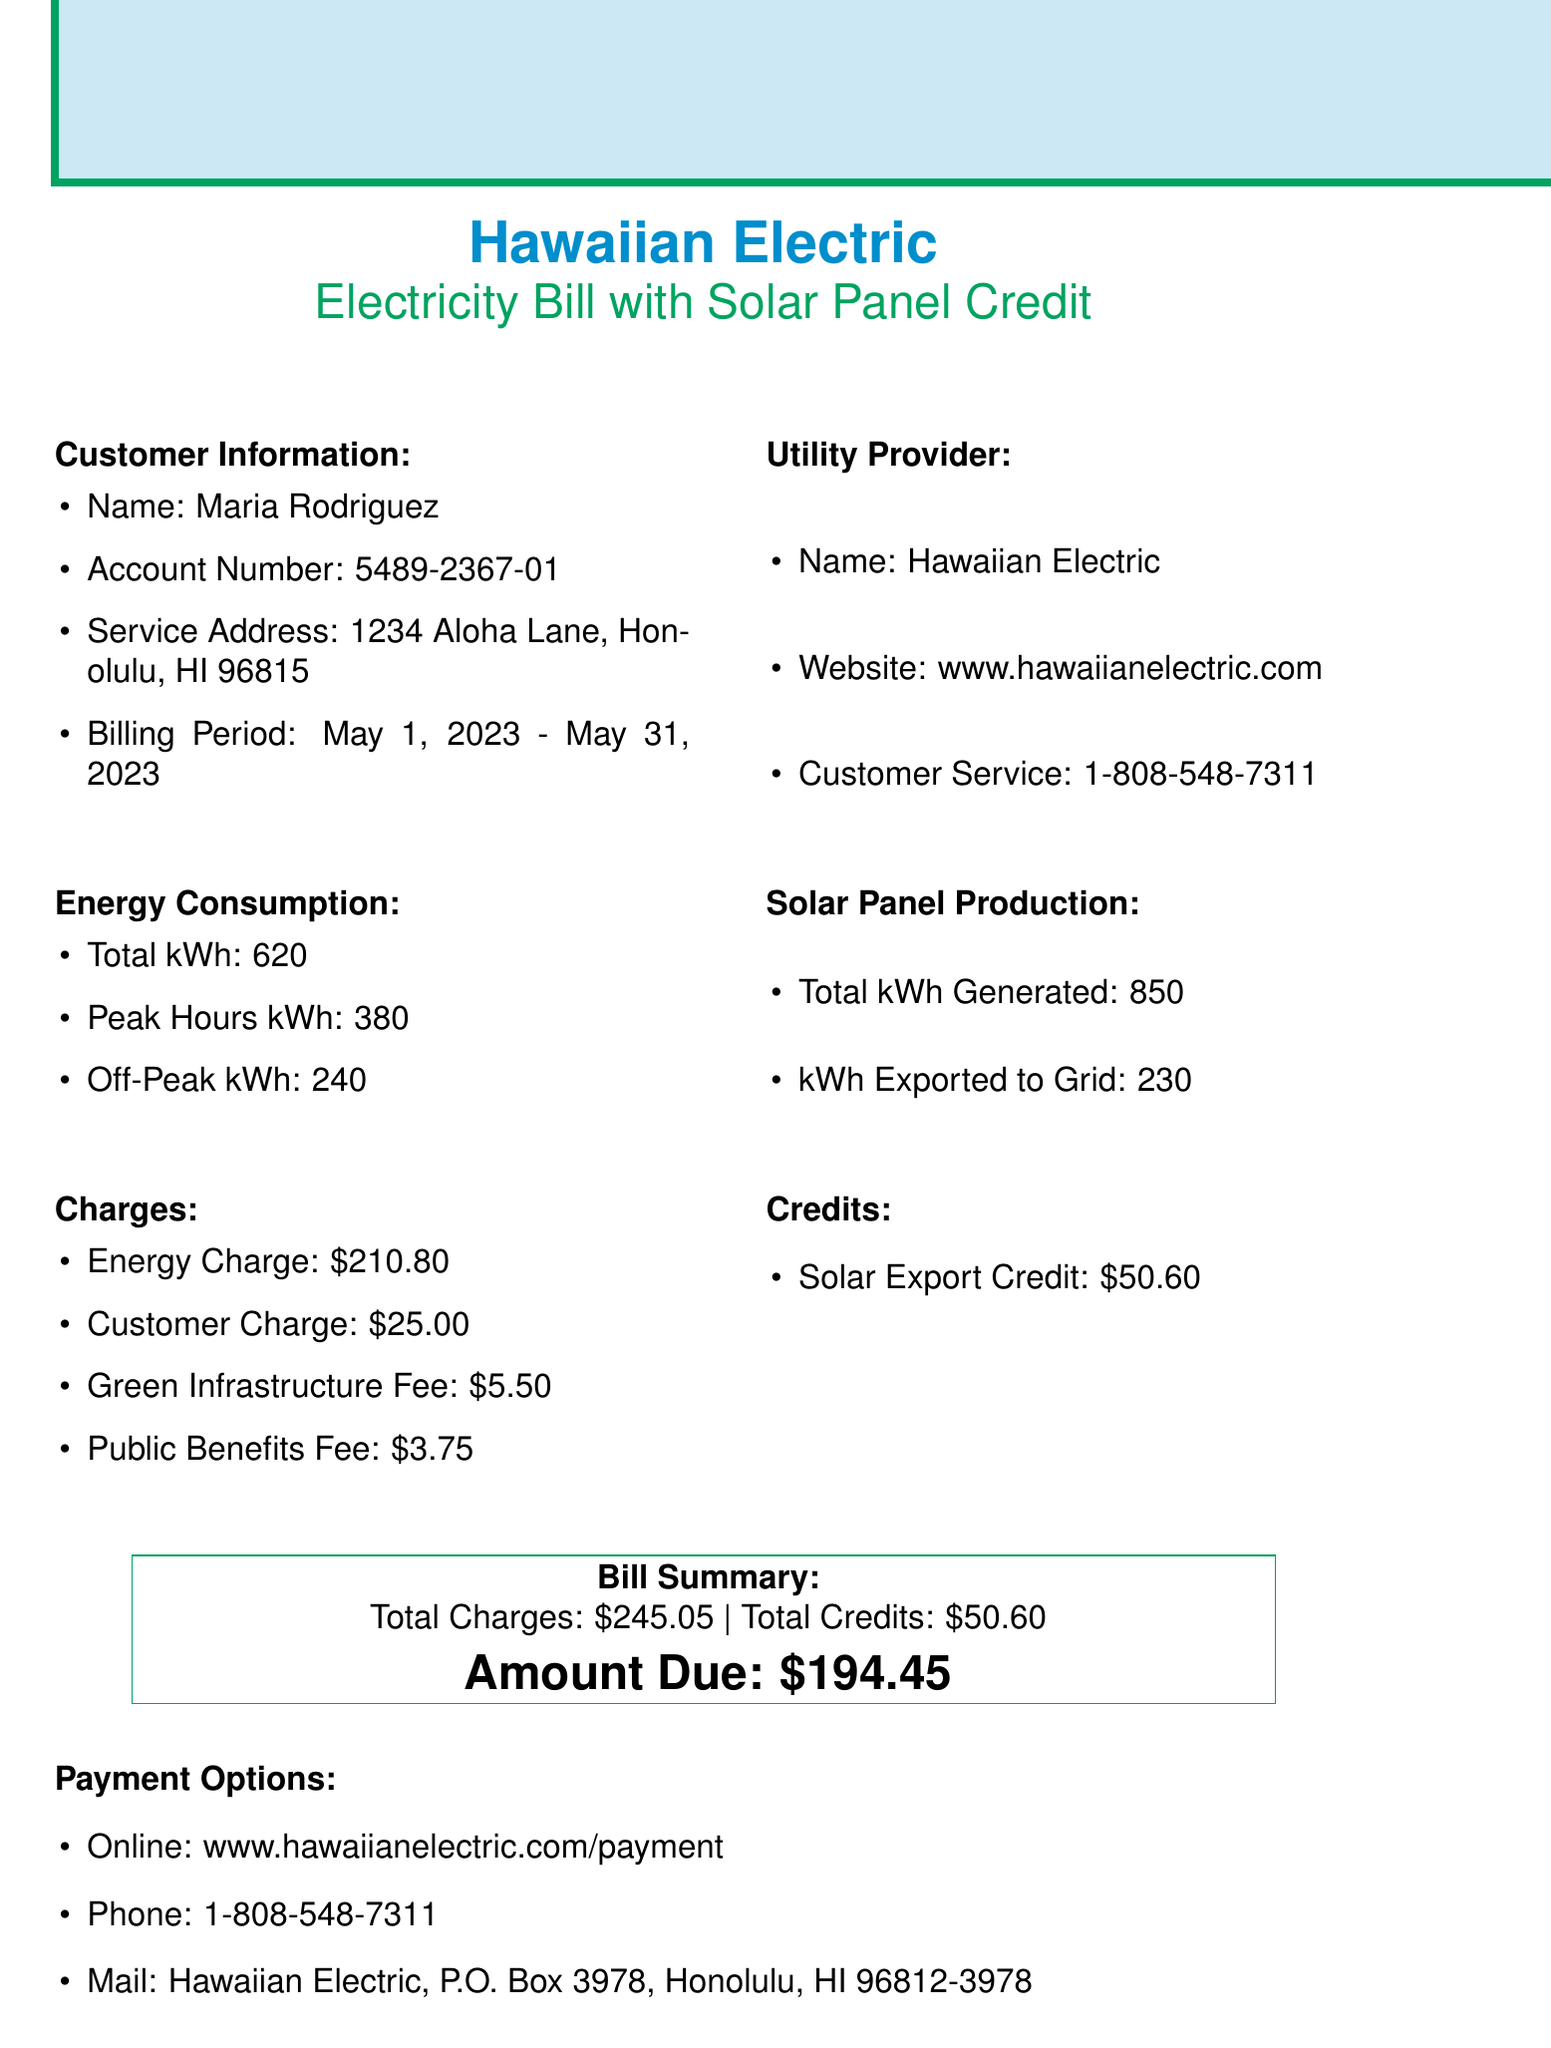what is the customer name? The customer name is listed under customer information.
Answer: Maria Rodriguez what is the billing period? The billing period is noted in the customer information section.
Answer: May 1, 2023 - May 31, 2023 how much is the total kWh consumed? The document specifies the total kWh consumed under energy consumption.
Answer: 620 what is the solar export credit amount? The solar export credit can be found in the credits section of the document.
Answer: 50.60 what is the amount due? The amount due is summarized in the bill summary section of the document.
Answer: 194.45 how many kWh were exported to the grid? The document states the exported kWh amount in the solar panel production area.
Answer: 230 what is the base rate per kWh? The base rate is detailed under rate details in the document.
Answer: 0.34 what service provider is listed for solar panel maintenance? The service provider for solar panel maintenance is noted in the solar panel maintenance section.
Answer: Aloha Solar Solutions name one energy saving tip provided in the document. Energy saving tips are listed under the energy saving tips section.
Answer: Use energy-efficient LED light bulbs 